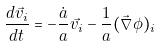<formula> <loc_0><loc_0><loc_500><loc_500>\frac { d \vec { v _ { i } } } { d t } = - \frac { \dot { a } } { a } \vec { v _ { i } } - \frac { 1 } { a } ( \vec { \nabla } \phi ) _ { i }</formula> 